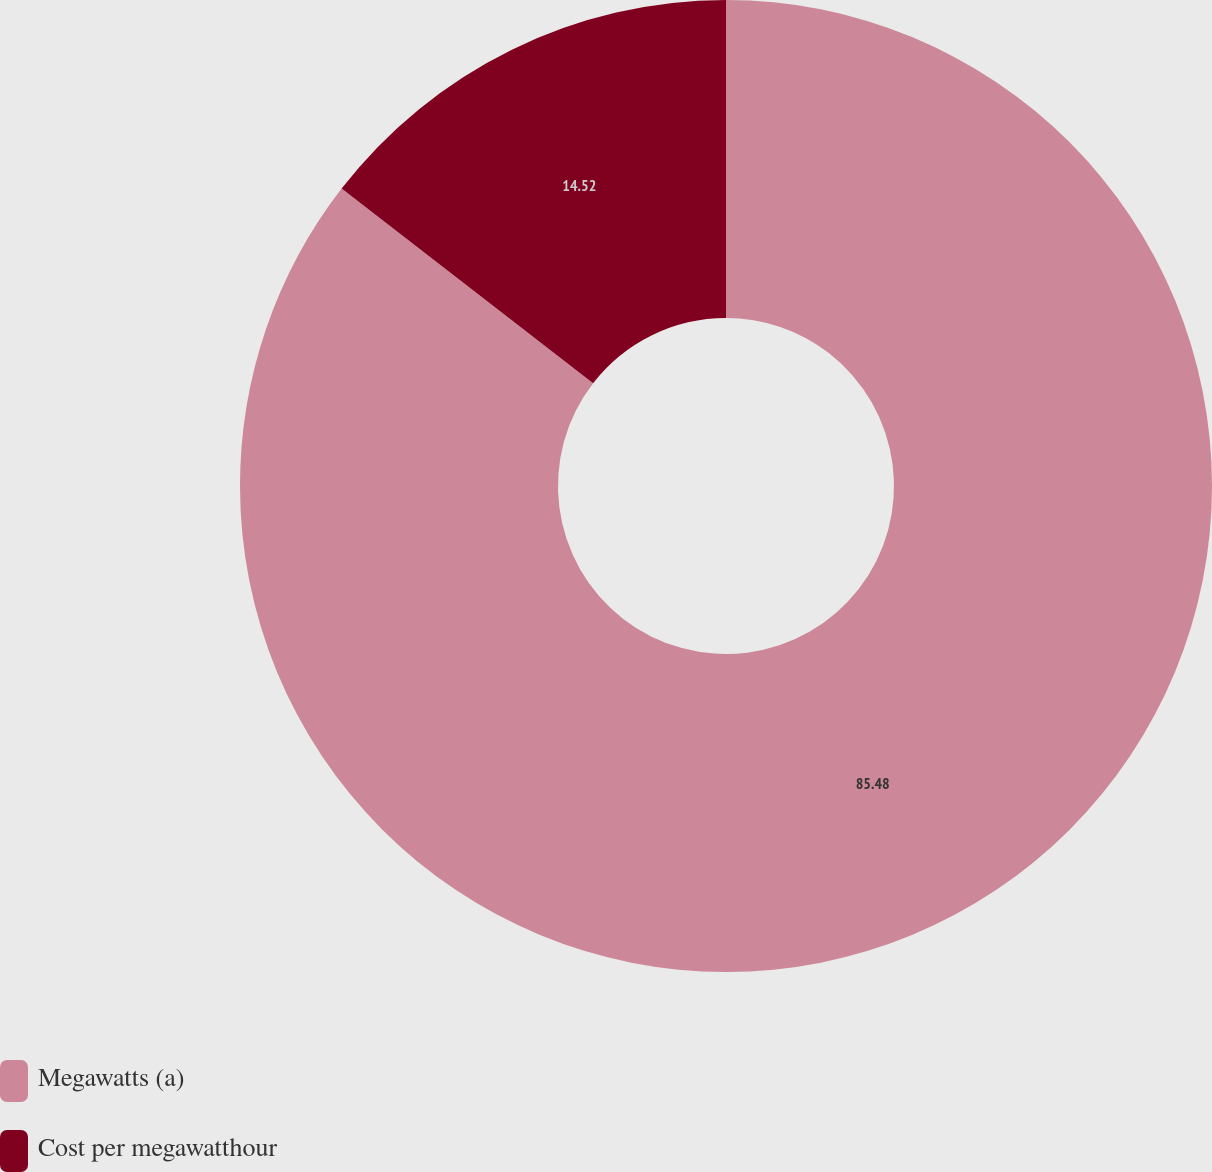Convert chart. <chart><loc_0><loc_0><loc_500><loc_500><pie_chart><fcel>Megawatts (a)<fcel>Cost per megawatthour<nl><fcel>85.48%<fcel>14.52%<nl></chart> 